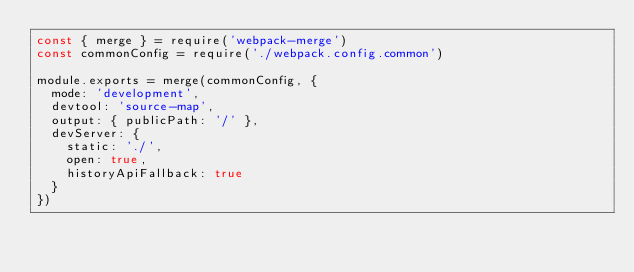Convert code to text. <code><loc_0><loc_0><loc_500><loc_500><_JavaScript_>const { merge } = require('webpack-merge')
const commonConfig = require('./webpack.config.common')

module.exports = merge(commonConfig, {
  mode: 'development',
  devtool: 'source-map',
  output: { publicPath: '/' },
  devServer: {
    static: './',
    open: true,
    historyApiFallback: true
  }
})</code> 